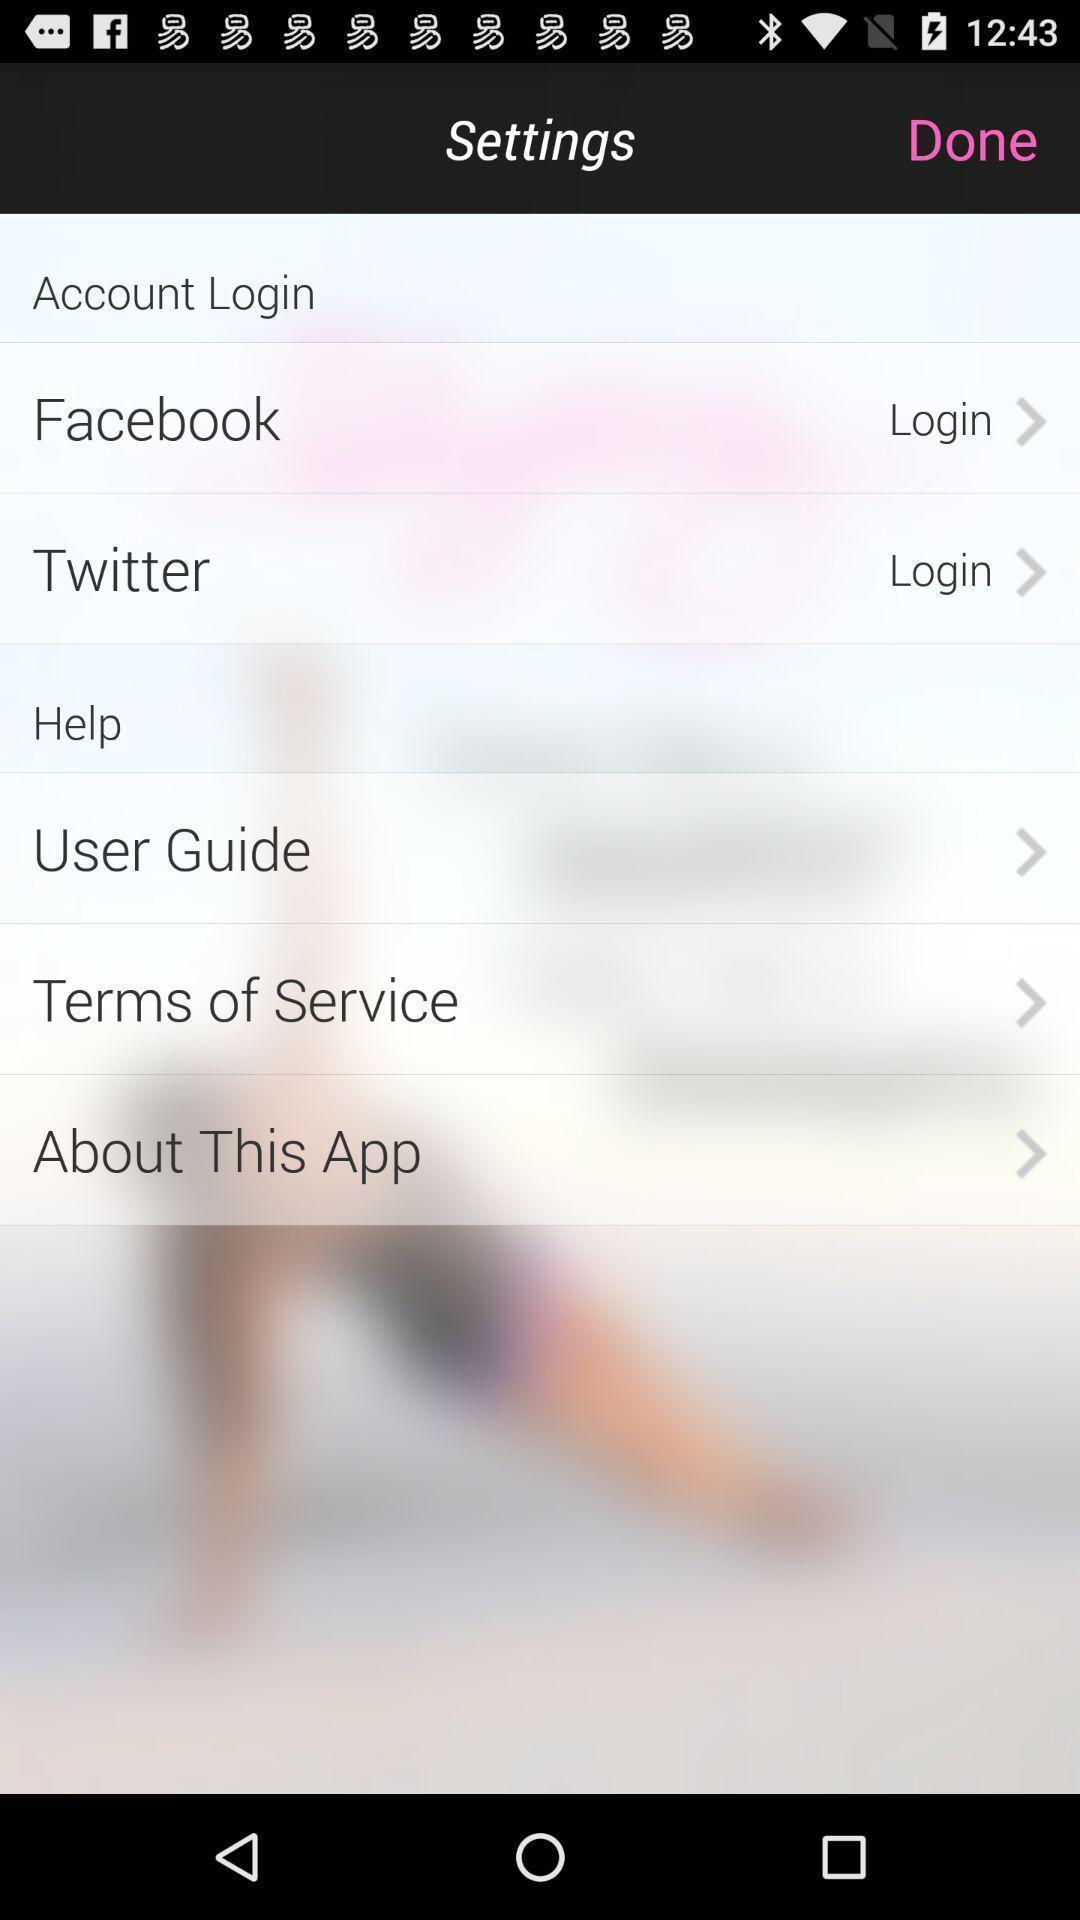Describe the content in this image. Settings page displayed for an application. 